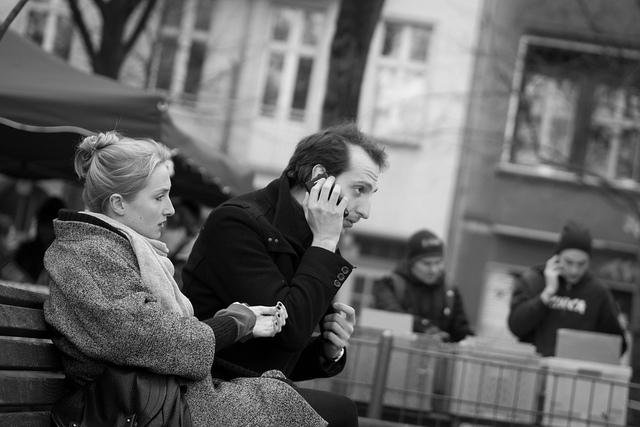Does this look like fun?
Be succinct. No. Is the weather most likely summer or fall?
Concise answer only. Fall. What is the weather outside?
Be succinct. Cold. How many people are wearing glasses?
Give a very brief answer. 0. What color is the photo?
Short answer required. Black and white. What's on the awning?
Give a very brief answer. Nothing. Does the lady have a cell phone to her ear?
Write a very short answer. No. Where is the man's hands standing in the picture?
Be succinct. On ear. What device is the man holding seated on the bench?
Give a very brief answer. Cell phone. Is she wearing a fur coat?
Be succinct. No. What is the color of the girls' hair?
Short answer required. Blonde. Are these old baseball players?
Short answer required. No. Is there a backpack in this picture?
Be succinct. No. Are the men observant?
Give a very brief answer. No. 